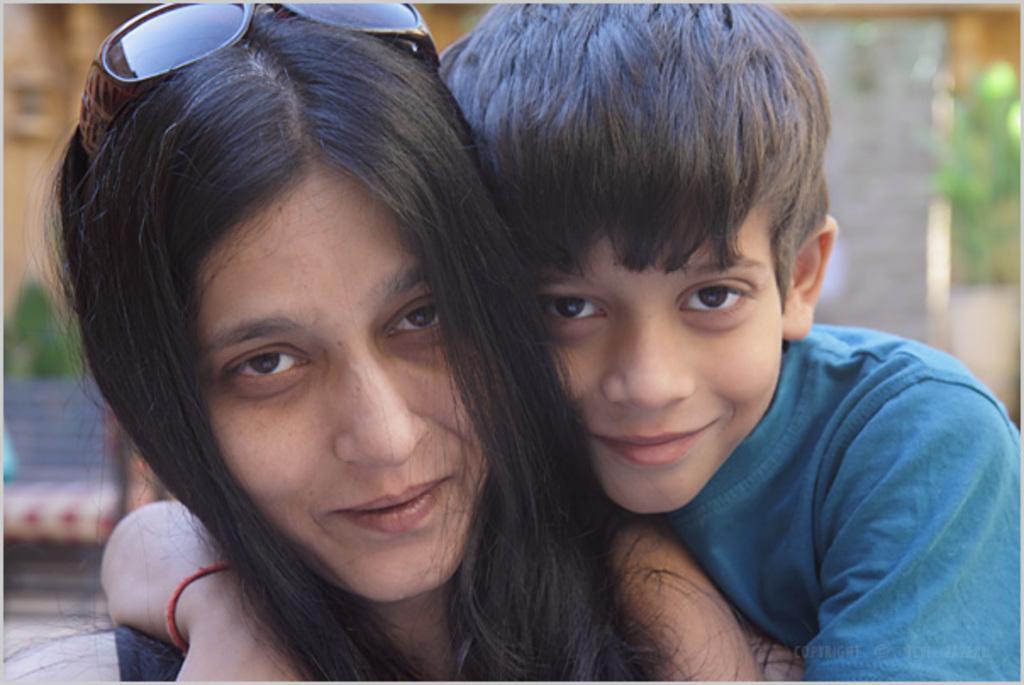In one or two sentences, can you explain what this image depicts? In this image I can see a woman and a boy are smiling and giving pose for the picture. On the woman's head I can see goggles. In the background there is a bench and a wall. 